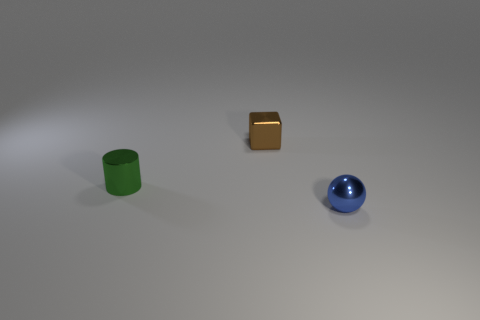Add 3 large yellow metallic things. How many objects exist? 6 Subtract all cylinders. How many objects are left? 2 Add 2 tiny brown blocks. How many tiny brown blocks are left? 3 Add 2 small shiny objects. How many small shiny objects exist? 5 Subtract 0 purple spheres. How many objects are left? 3 Subtract all tiny red objects. Subtract all tiny blue metal balls. How many objects are left? 2 